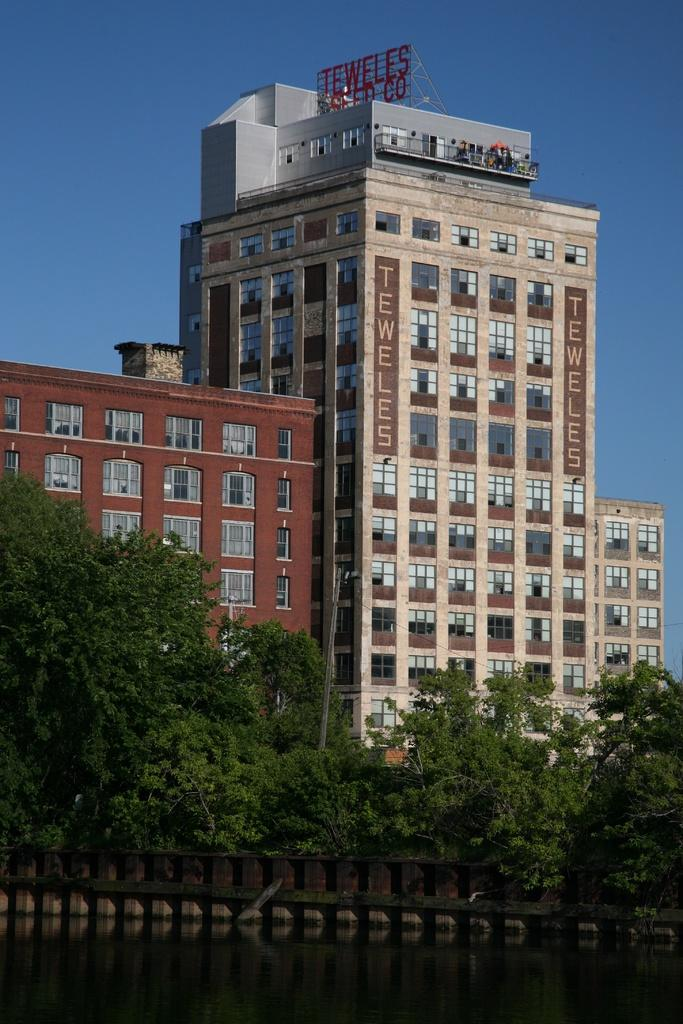What is present in the image that is not a solid object? There is water visible in the image. What is the color of the black object in the image? The black colored object in the image is black. What is the color of the trees in the image? The trees in the image are green in color. What type of structures can be seen in the image? There are buildings in the image. What can be seen in the background of the image? The sky is visible in the background of the image. Can you tell me how the sock is feeling in the image? There is no sock present in the image. 